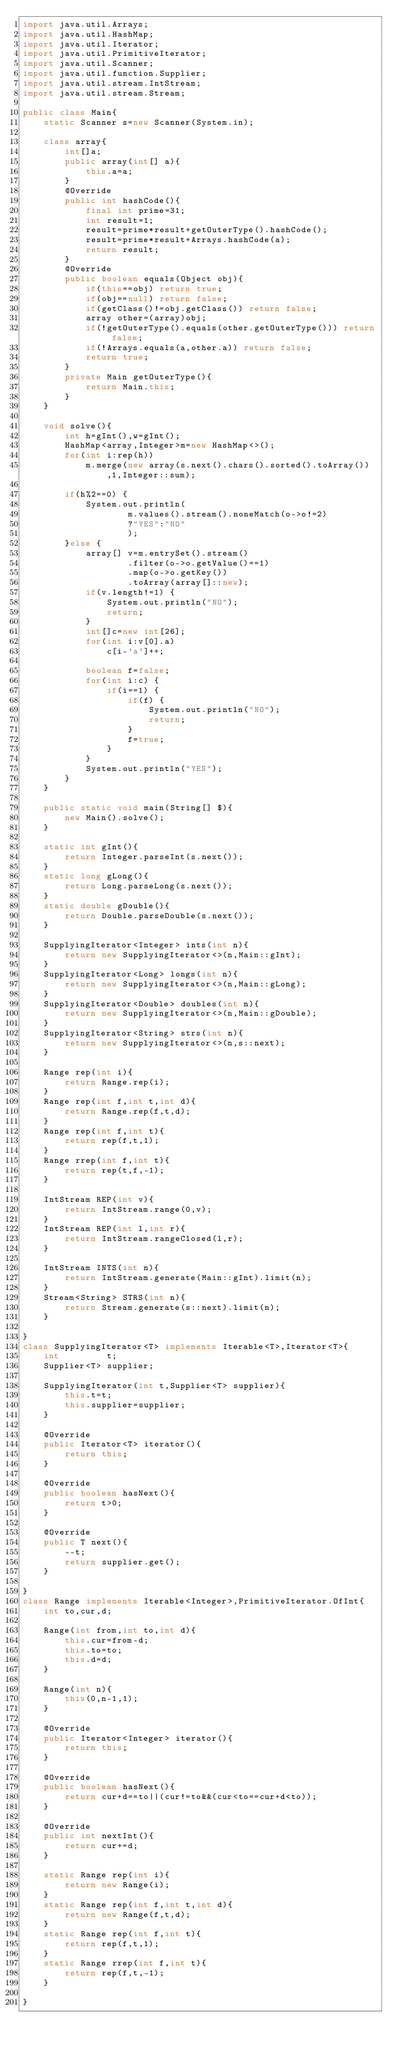<code> <loc_0><loc_0><loc_500><loc_500><_Java_>import java.util.Arrays;
import java.util.HashMap;
import java.util.Iterator;
import java.util.PrimitiveIterator;
import java.util.Scanner;
import java.util.function.Supplier;
import java.util.stream.IntStream;
import java.util.stream.Stream;

public class Main{
	static Scanner s=new Scanner(System.in);

	class array{
		int[]a;
		public array(int[] a){
			this.a=a;
		}
		@Override
		public int hashCode(){
			final int prime=31;
			int result=1;
			result=prime*result+getOuterType().hashCode();
			result=prime*result+Arrays.hashCode(a);
			return result;
		}
		@Override
		public boolean equals(Object obj){
			if(this==obj) return true;
			if(obj==null) return false;
			if(getClass()!=obj.getClass()) return false;
			array other=(array)obj;
			if(!getOuterType().equals(other.getOuterType())) return false;
			if(!Arrays.equals(a,other.a)) return false;
			return true;
		}
		private Main getOuterType(){
			return Main.this;
		}
	}

	void solve(){
		int h=gInt(),w=gInt();
		HashMap<array,Integer>m=new HashMap<>();
		for(int i:rep(h))
			m.merge(new array(s.next().chars().sorted().toArray()),1,Integer::sum);

		if(h%2==0) {
			System.out.println(
					m.values().stream().noneMatch(o->o!=2)
					?"YES":"NO"
					);
		}else {
			array[] v=m.entrySet().stream()
					.filter(o->o.getValue()==1)
					.map(o->o.getKey())
					.toArray(array[]::new);
			if(v.length!=1) {
				System.out.println("NO");
				return;
			}
			int[]c=new int[26];
			for(int i:v[0].a)
				c[i-'a']++;

			boolean f=false;
			for(int i:c) {
				if(i==1) {
					if(f) {
						System.out.println("NO");
						return;
					}
					f=true;
				}
			}
			System.out.println("YES");
		}
	}

	public static void main(String[] $){
		new Main().solve();
	}

	static int gInt(){
		return Integer.parseInt(s.next());
	}
	static long gLong(){
		return Long.parseLong(s.next());
	}
	static double gDouble(){
		return Double.parseDouble(s.next());
	}

	SupplyingIterator<Integer> ints(int n){
		return new SupplyingIterator<>(n,Main::gInt);
	}
	SupplyingIterator<Long> longs(int n){
		return new SupplyingIterator<>(n,Main::gLong);
	}
	SupplyingIterator<Double> doubles(int n){
		return new SupplyingIterator<>(n,Main::gDouble);
	}
	SupplyingIterator<String> strs(int n){
		return new SupplyingIterator<>(n,s::next);
	}

	Range rep(int i){
		return Range.rep(i);
	}
	Range rep(int f,int t,int d){
		return Range.rep(f,t,d);
	}
	Range rep(int f,int t){
		return rep(f,t,1);
	}
	Range rrep(int f,int t){
		return rep(t,f,-1);
	}

	IntStream REP(int v){
		return IntStream.range(0,v);
	}
	IntStream REP(int l,int r){
		return IntStream.rangeClosed(l,r);
	}

	IntStream INTS(int n){
		return IntStream.generate(Main::gInt).limit(n);
	}
	Stream<String> STRS(int n){
		return Stream.generate(s::next).limit(n);
	}

}
class SupplyingIterator<T> implements Iterable<T>,Iterator<T>{
	int			t;
	Supplier<T>	supplier;

	SupplyingIterator(int t,Supplier<T> supplier){
		this.t=t;
		this.supplier=supplier;
	}

	@Override
	public Iterator<T> iterator(){
		return this;
	}

	@Override
	public boolean hasNext(){
		return t>0;
	}

	@Override
	public T next(){
		--t;
		return supplier.get();
	}

}
class Range implements Iterable<Integer>,PrimitiveIterator.OfInt{
	int to,cur,d;

	Range(int from,int to,int d){
		this.cur=from-d;
		this.to=to;
		this.d=d;
	}

	Range(int n){
		this(0,n-1,1);
	}

	@Override
	public Iterator<Integer> iterator(){
		return this;
	}

	@Override
	public boolean hasNext(){
		return cur+d==to||(cur!=to&&(cur<to==cur+d<to));
	}

	@Override
	public int nextInt(){
		return cur+=d;
	}

	static Range rep(int i){
		return new Range(i);
	}
	static Range rep(int f,int t,int d){
		return new Range(f,t,d);
	}
	static Range rep(int f,int t){
		return rep(f,t,1);
	}
	static Range rrep(int f,int t){
		return rep(f,t,-1);
	}

}
</code> 